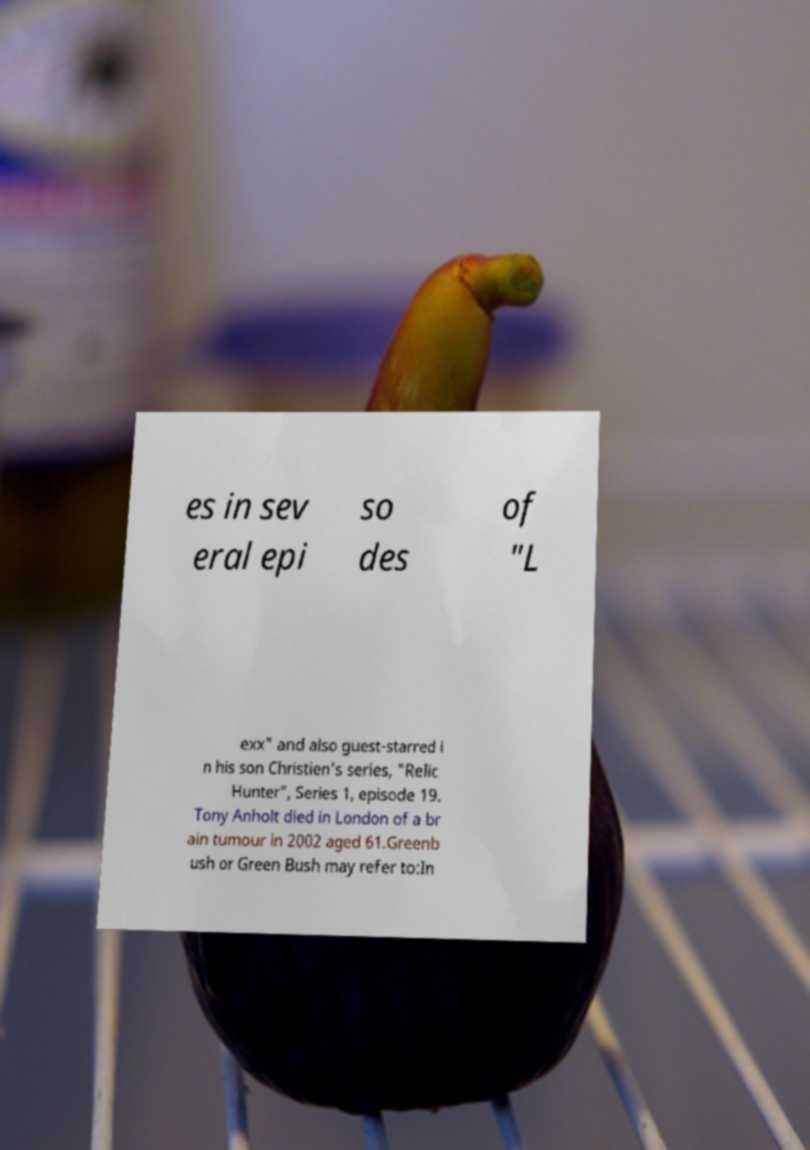Please identify and transcribe the text found in this image. es in sev eral epi so des of "L exx" and also guest-starred i n his son Christien's series, "Relic Hunter", Series 1, episode 19. Tony Anholt died in London of a br ain tumour in 2002 aged 61.Greenb ush or Green Bush may refer to:In 